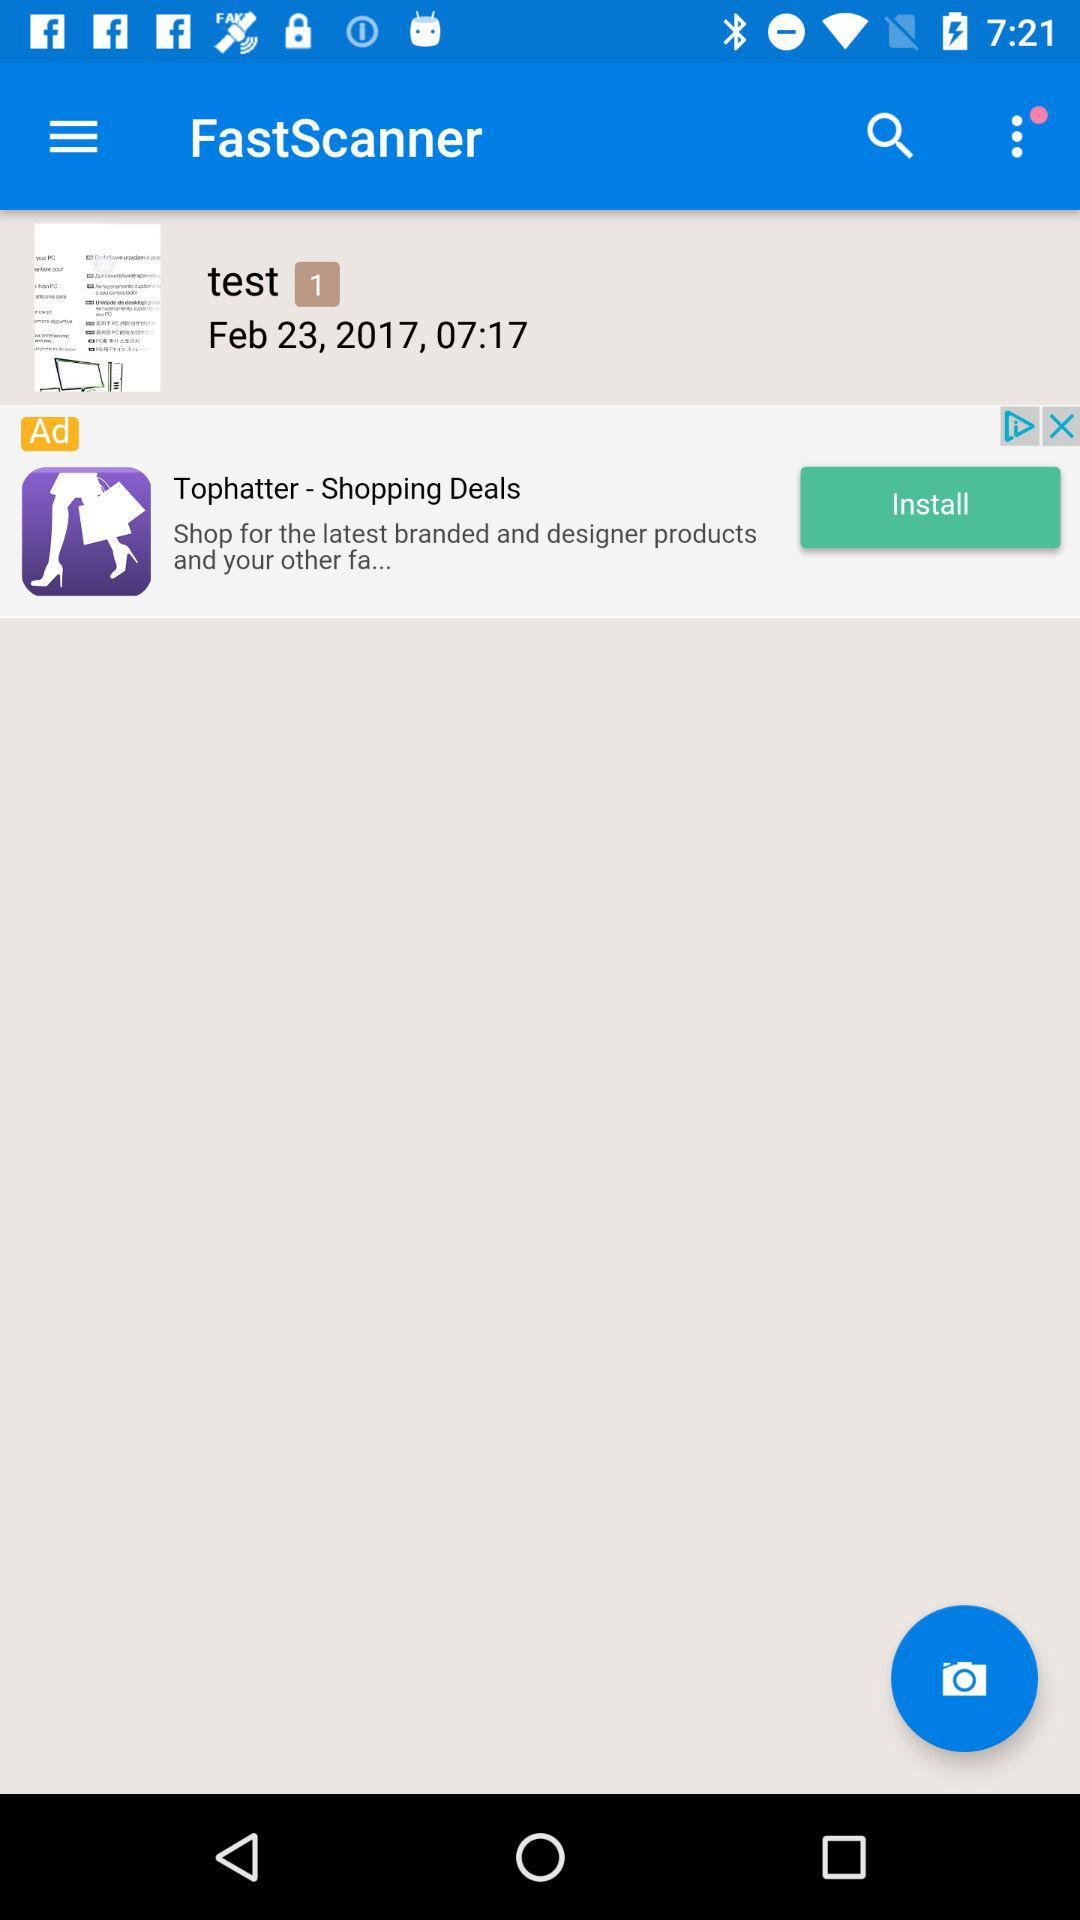At what time was the "test" image saved? The "test" image was saved at 07:17. 